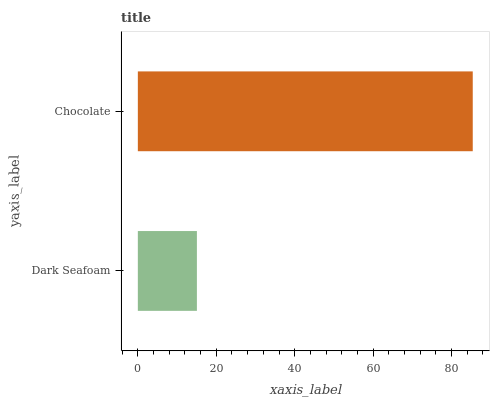Is Dark Seafoam the minimum?
Answer yes or no. Yes. Is Chocolate the maximum?
Answer yes or no. Yes. Is Chocolate the minimum?
Answer yes or no. No. Is Chocolate greater than Dark Seafoam?
Answer yes or no. Yes. Is Dark Seafoam less than Chocolate?
Answer yes or no. Yes. Is Dark Seafoam greater than Chocolate?
Answer yes or no. No. Is Chocolate less than Dark Seafoam?
Answer yes or no. No. Is Chocolate the high median?
Answer yes or no. Yes. Is Dark Seafoam the low median?
Answer yes or no. Yes. Is Dark Seafoam the high median?
Answer yes or no. No. Is Chocolate the low median?
Answer yes or no. No. 